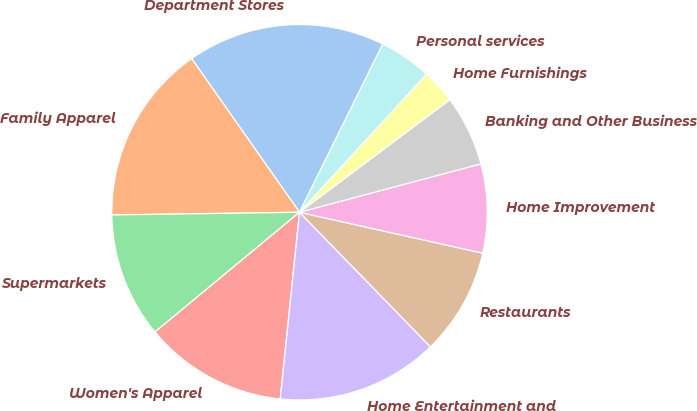<chart> <loc_0><loc_0><loc_500><loc_500><pie_chart><fcel>Department Stores<fcel>Family Apparel<fcel>Supermarkets<fcel>Women's Apparel<fcel>Home Entertainment and<fcel>Restaurants<fcel>Home Improvement<fcel>Banking and Other Business<fcel>Home Furnishings<fcel>Personal services<nl><fcel>17.06%<fcel>15.49%<fcel>10.78%<fcel>12.35%<fcel>13.92%<fcel>9.22%<fcel>7.65%<fcel>6.08%<fcel>2.94%<fcel>4.51%<nl></chart> 